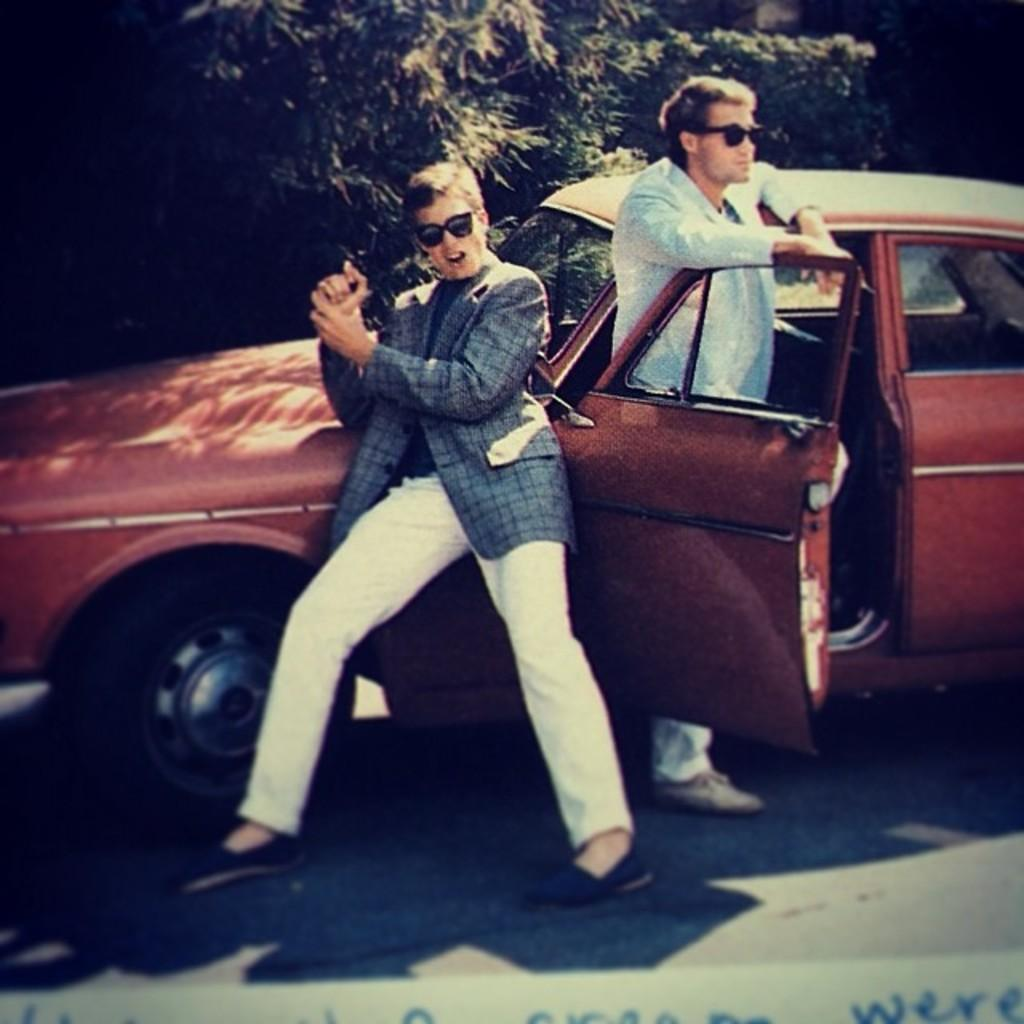Where was the image taken? The image was taken outside of a car. Can you describe the person on the right side of the image? The person on the right side is holding a car door. What is the position of the person on the left side of the image? The person on the left side is standing. Are there any other people visible in the image? No, there are only two people visible in the image. What type of bait is being used to catch fish in the image? There is no mention of fishing or bait in the image; it features two people outside of a car. Is the image taken during a snowstorm? No, there is no indication of snow or a snowstorm in the image. 